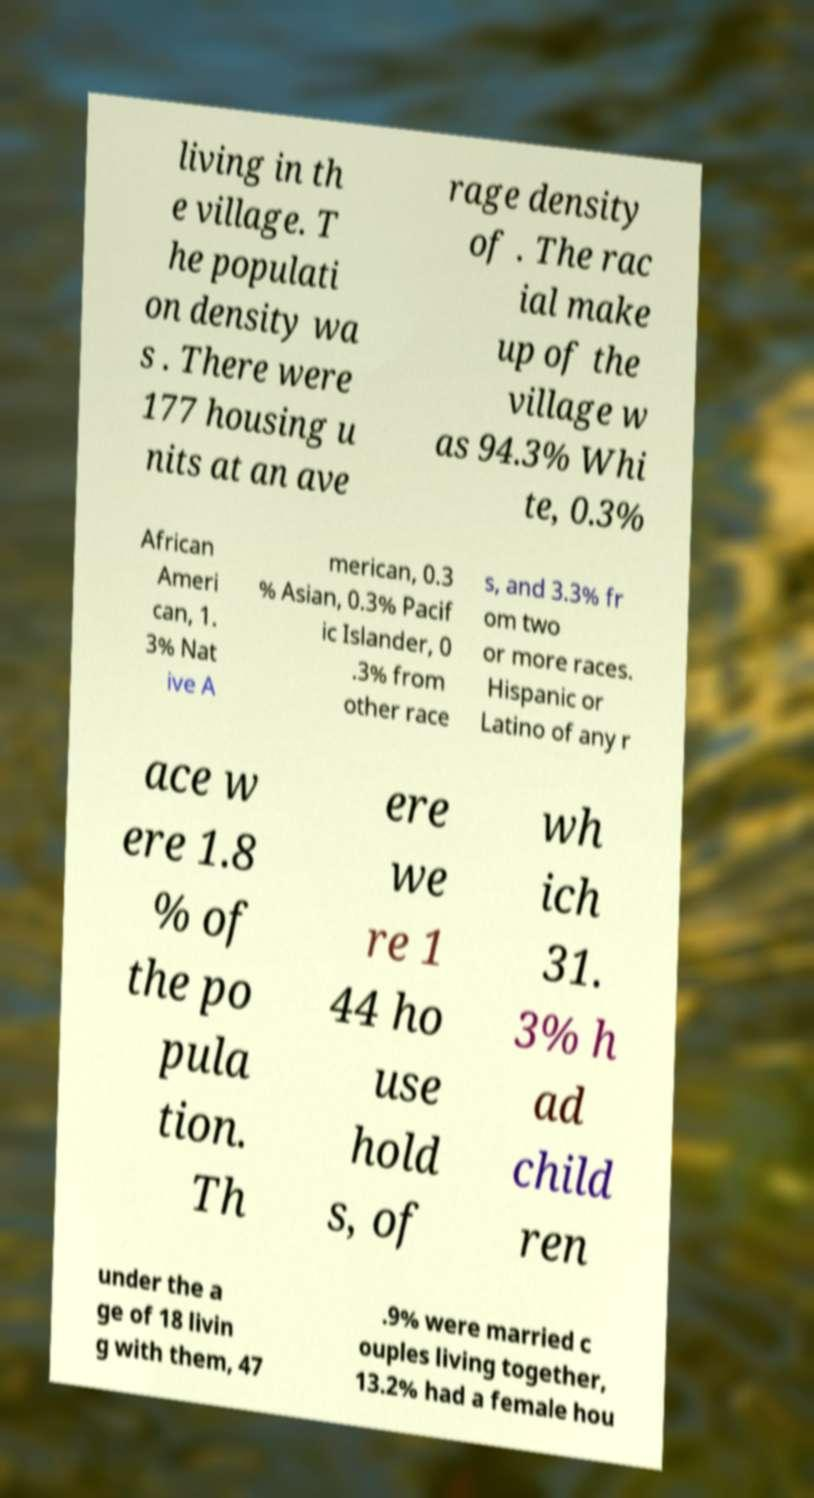What messages or text are displayed in this image? I need them in a readable, typed format. living in th e village. T he populati on density wa s . There were 177 housing u nits at an ave rage density of . The rac ial make up of the village w as 94.3% Whi te, 0.3% African Ameri can, 1. 3% Nat ive A merican, 0.3 % Asian, 0.3% Pacif ic Islander, 0 .3% from other race s, and 3.3% fr om two or more races. Hispanic or Latino of any r ace w ere 1.8 % of the po pula tion. Th ere we re 1 44 ho use hold s, of wh ich 31. 3% h ad child ren under the a ge of 18 livin g with them, 47 .9% were married c ouples living together, 13.2% had a female hou 